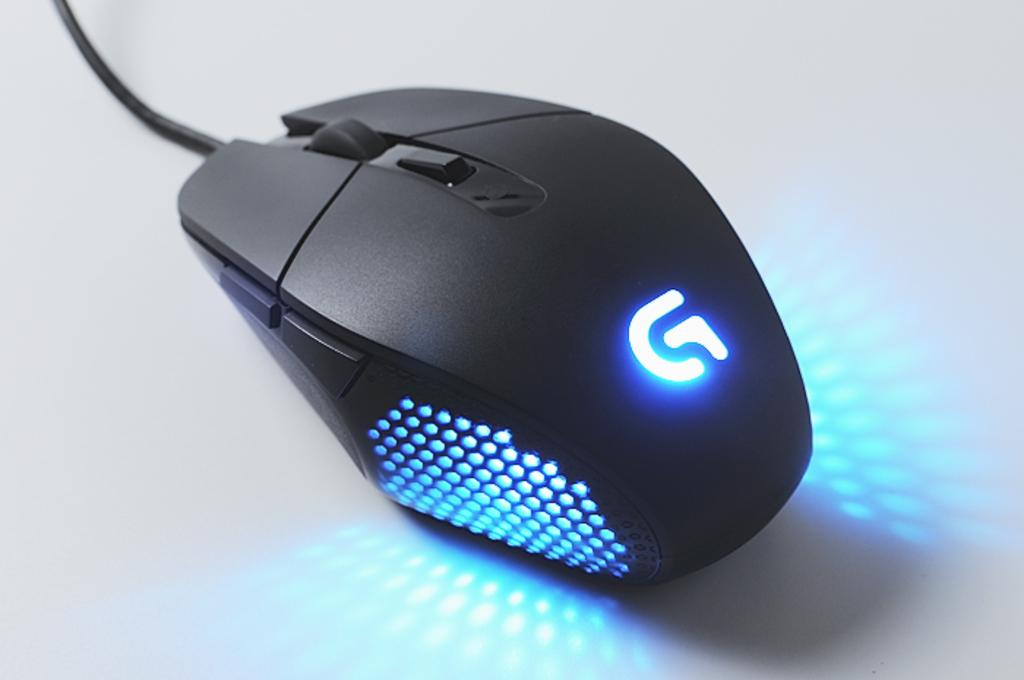<image>
Describe the image concisely. A Logitech G-series mouse is lit up with blue RGB lighting. 